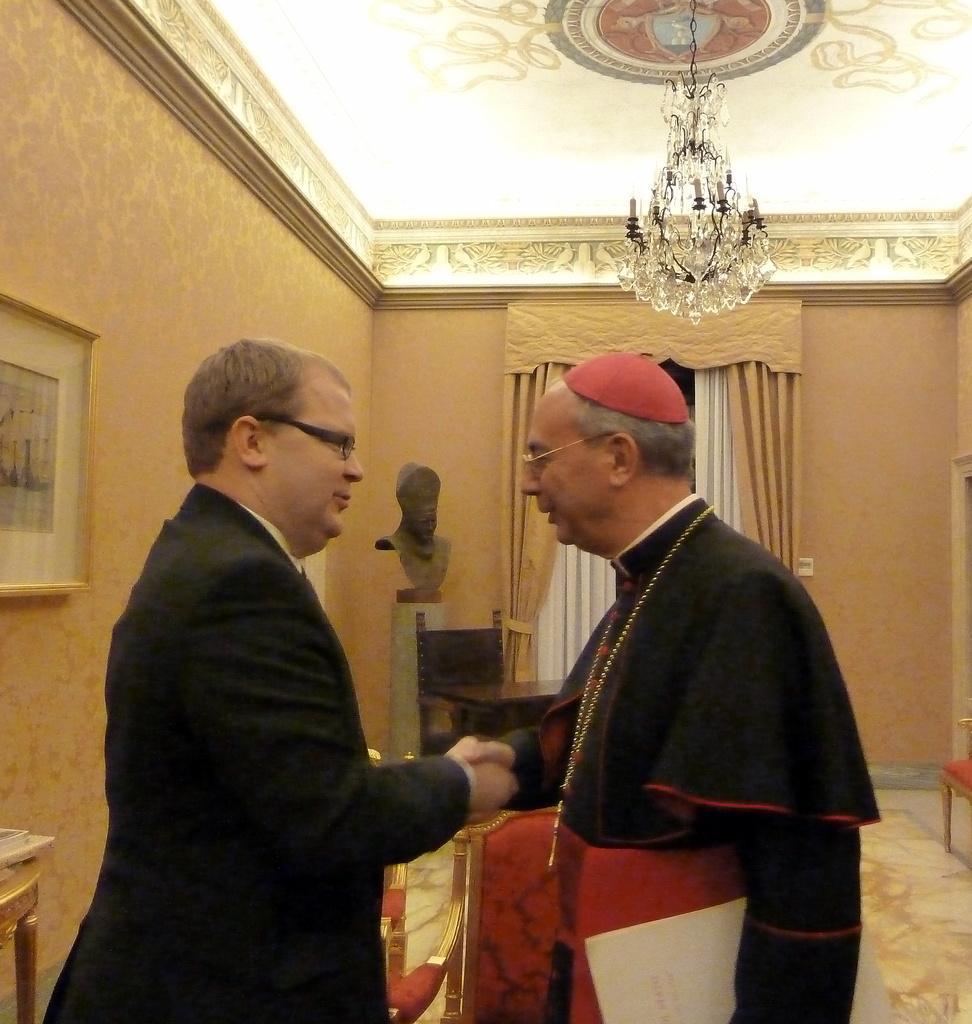Can you describe this image briefly? In the center of the image we can see two people standing and shaking their hands. In the background there are chairs and tables. There is a sculpture and we can see curtains. On the left there is a frame placed on the wall. At the top there is a chandelier. 